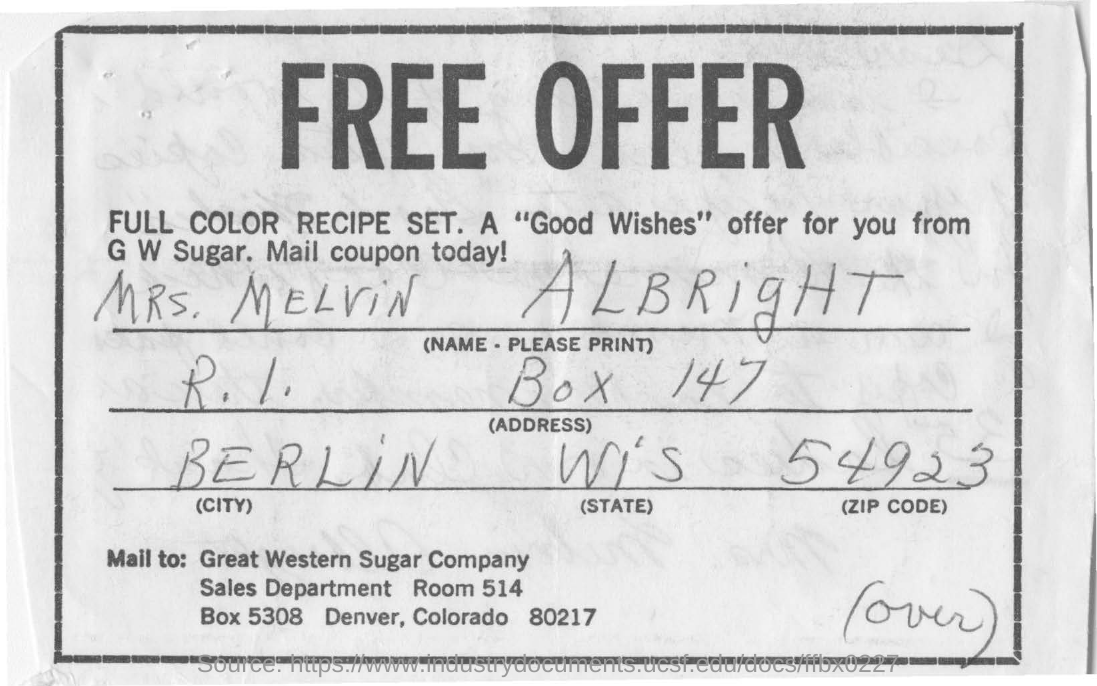What is the name of the person in this document?
Offer a very short reply. Mrs. Melvin Albright. Which city does Mrs. Melvin Albright belongs to?
Provide a succinct answer. Berlin. What is the zipcode no  given?
Keep it short and to the point. 54923. 